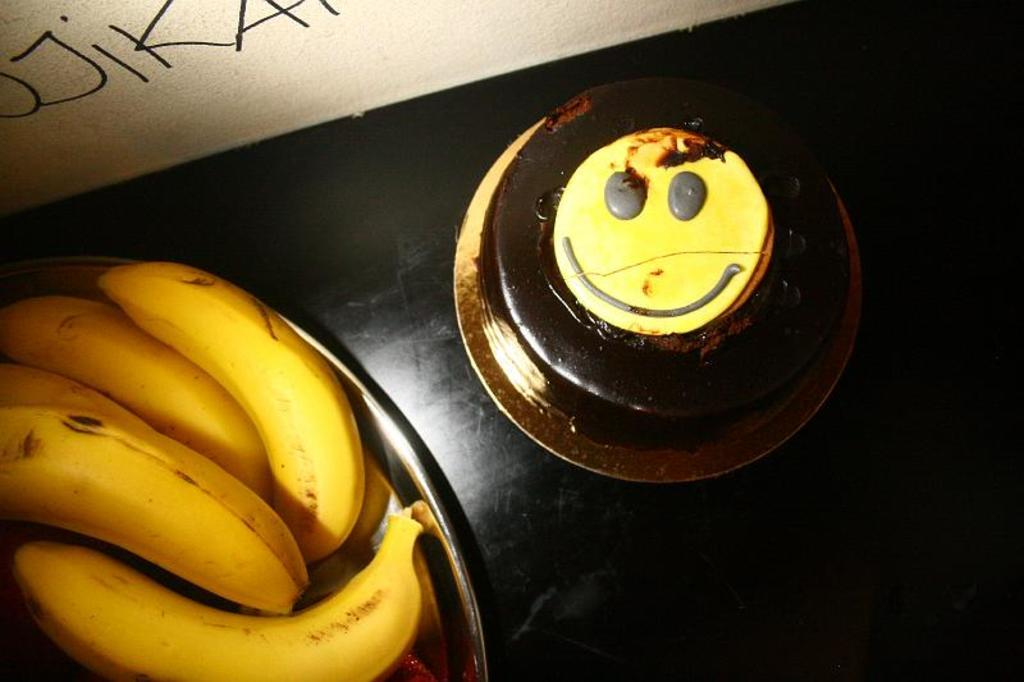What piece of furniture is in the image? There is a table in the image. What is placed on the table? A plate is placed on the table. What is on the plate? The plate contains bananas and a cake. What can be seen behind the table? There is a wall visible in the image. What is written or drawn on the wall? Text is present on the wall. What type of hat is the banana wearing in the image? There are no hats present in the image, and the bananas are not wearing any clothing or accessories. Can you tell me how many spoons are visible in the image? There is no mention of spoons in the provided facts, so it cannot be determined from the image. 